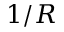<formula> <loc_0><loc_0><loc_500><loc_500>1 / R</formula> 